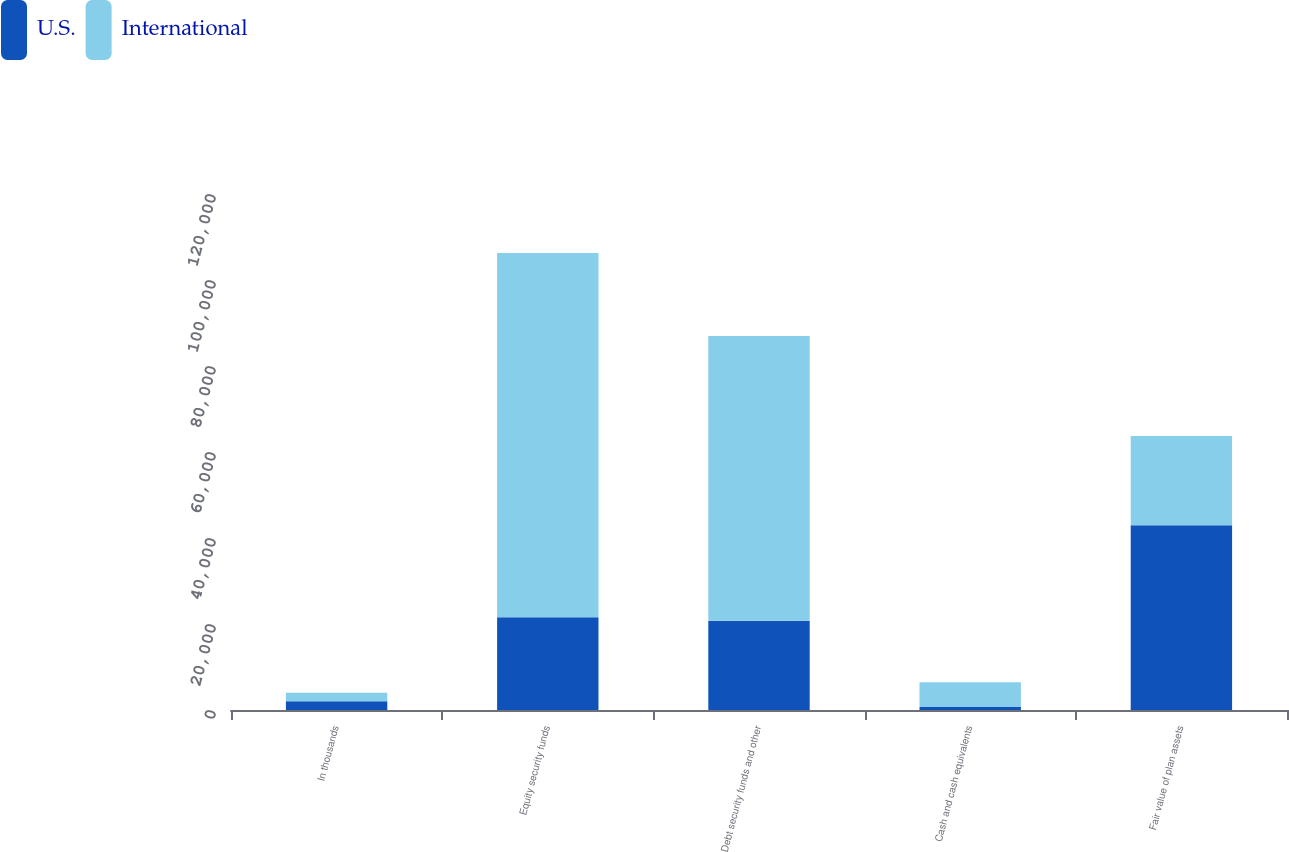Convert chart to OTSL. <chart><loc_0><loc_0><loc_500><loc_500><stacked_bar_chart><ecel><fcel>In thousands<fcel>Equity security funds<fcel>Debt security funds and other<fcel>Cash and cash equivalents<fcel>Fair value of plan assets<nl><fcel>U.S.<fcel>2013<fcel>21562<fcel>20749<fcel>669<fcel>42980<nl><fcel>International<fcel>2013<fcel>84699<fcel>66238<fcel>5768<fcel>20749<nl></chart> 